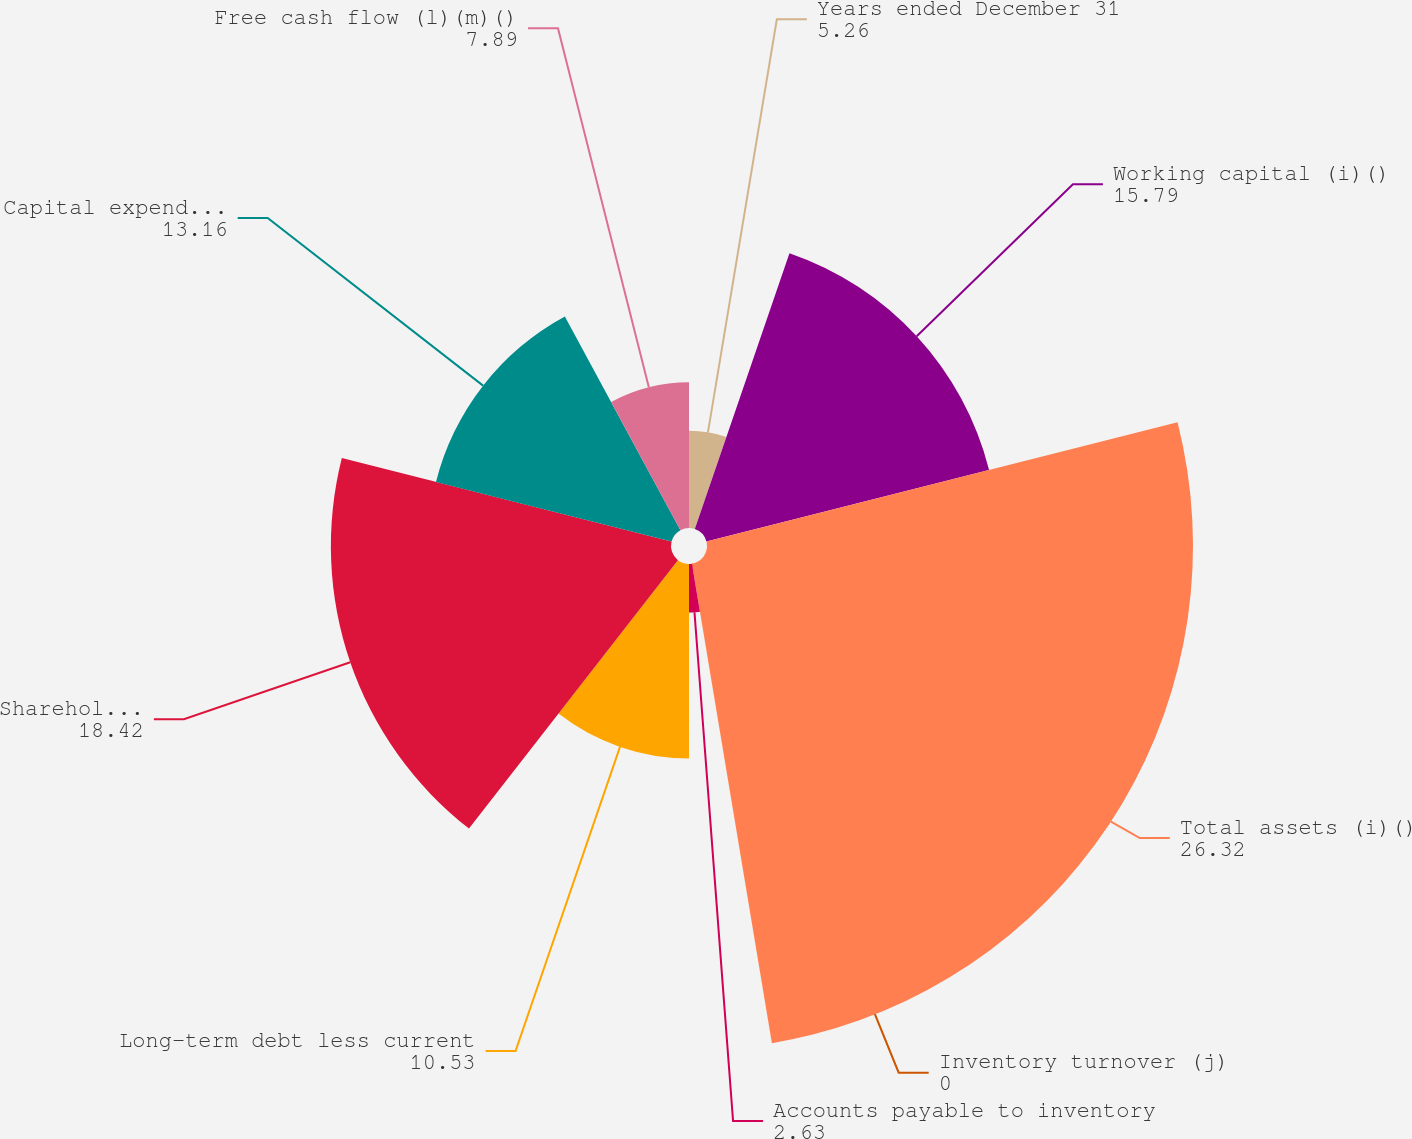Convert chart to OTSL. <chart><loc_0><loc_0><loc_500><loc_500><pie_chart><fcel>Years ended December 31<fcel>Working capital (i)()<fcel>Total assets (i)()<fcel>Inventory turnover (j)<fcel>Accounts payable to inventory<fcel>Long-term debt less current<fcel>Shareholders' equity () (a)<fcel>Capital expenditures ()<fcel>Free cash flow (l)(m)()<nl><fcel>5.26%<fcel>15.79%<fcel>26.32%<fcel>0.0%<fcel>2.63%<fcel>10.53%<fcel>18.42%<fcel>13.16%<fcel>7.89%<nl></chart> 